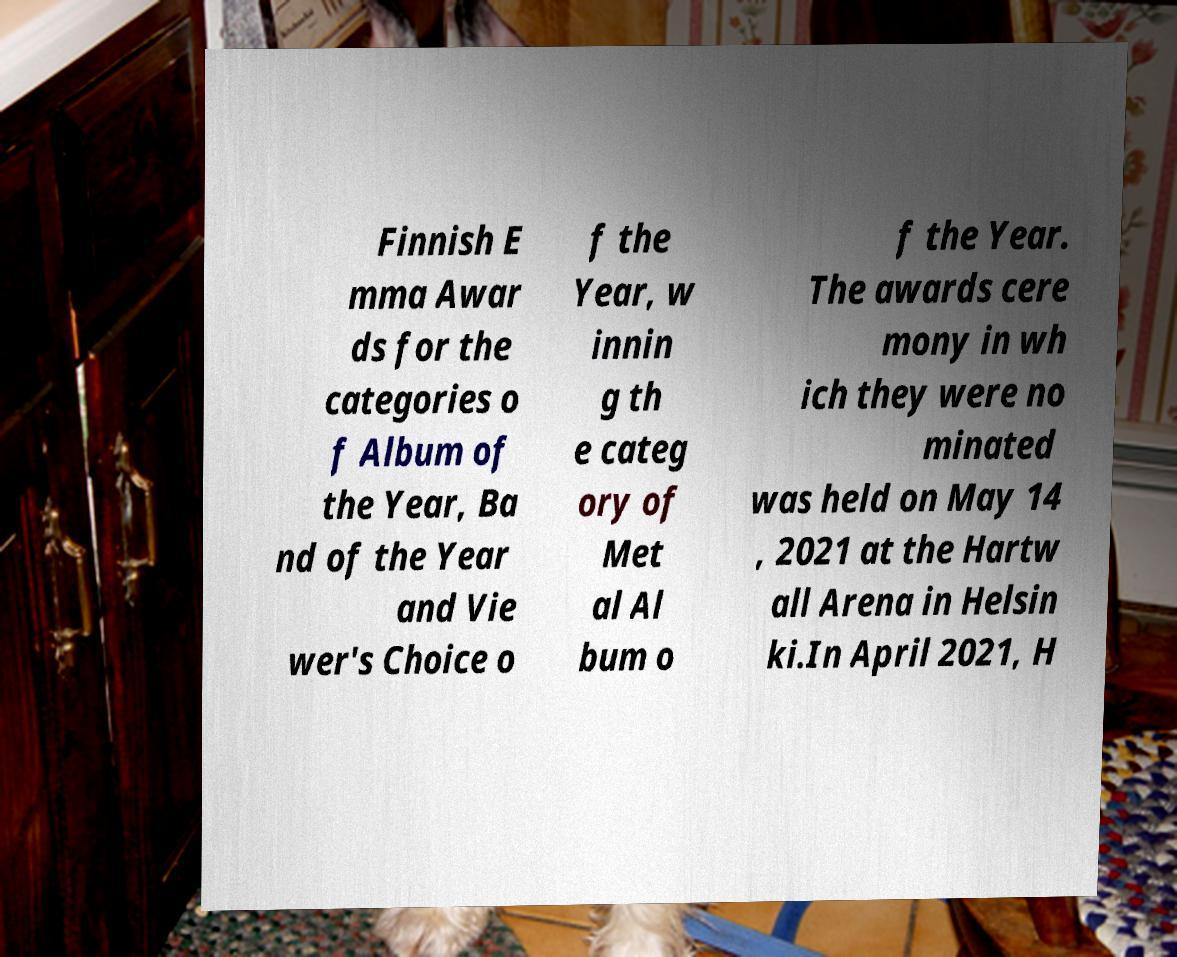Please identify and transcribe the text found in this image. Finnish E mma Awar ds for the categories o f Album of the Year, Ba nd of the Year and Vie wer's Choice o f the Year, w innin g th e categ ory of Met al Al bum o f the Year. The awards cere mony in wh ich they were no minated was held on May 14 , 2021 at the Hartw all Arena in Helsin ki.In April 2021, H 